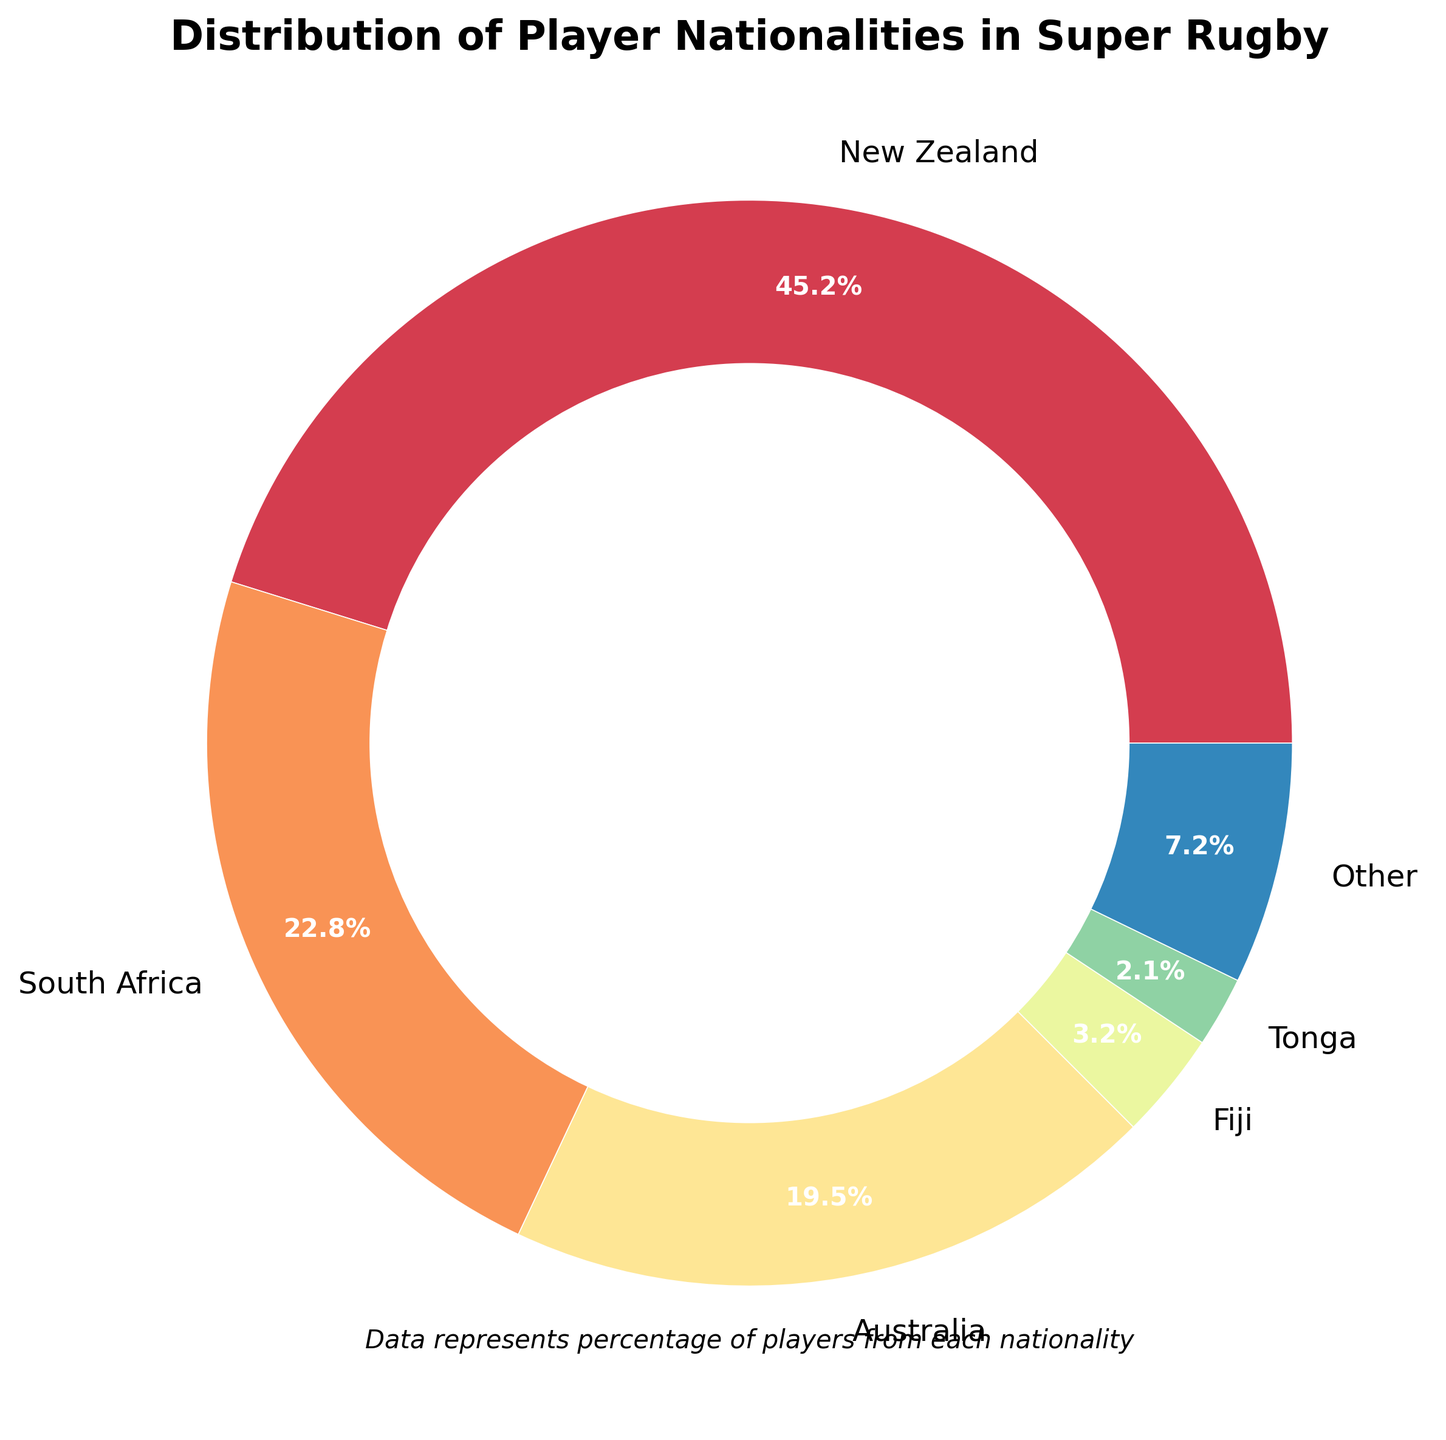Which nationality has the highest percentage of players in Super Rugby? The nationality with the highest percentage is easily identified by the largest section in the pie chart.
Answer: New Zealand How much higher is the percentage of New Zealand players compared to South African players? Subtract the percentage of South African players from the percentage of New Zealand players: 45.2% - 22.8% = 22.4%
Answer: 22.4% What is the sum of percentages for the three most represented nationalities? Add the percentages for New Zealand, South Africa, and Australia: 45.2% + 22.8% + 19.5% = 87.5%
Answer: 87.5% Do players from Fiji, Tonga, and Samoa together have a higher or lower percentage than Australian players? Sum the percentages of Fiji, Tonga, and Samoa and compare with the percentage for Australia: 3.2% + 2.1% + 1.8% = 7.1%. Since 7.1% < 19.5%, it's lower.
Answer: Lower How many nationalities are represented with a percentage less than 2%? Count the nationalities with percentages less than 2%: Samoa, Argentina, Japan, Pacific Islands, and Other (5 total).
Answer: 5 Which group has a larger percentage, Fiji alone or the combined percentage of Japan and Argentina? Compare the percentage of Fiji with the sum of percentages for Japan and Argentina: 3.2% vs. 1.2% + 1.5% = 2.7%. Fiji has a larger percentage.
Answer: Fiji What is the percentage difference between the smallest and the largest nationality representation? Subtract the smallest percentage (Pacific Islands 0.9%) from the largest percentage (New Zealand 45.2%): 45.2% - 0.9% = 44.3%
Answer: 44.3% If we combine the percentages of the players from the Pacific Islands, what would be their total percentage? Add the percentages for Fiji, Tonga, Samoa, and the Pacific Islands: 3.2% + 2.1% + 1.8% + 0.9% = 8.0%
Answer: 8.0% What percentage of players is represented by nationalities other than New Zealand, South Africa, and Australia? Sum the percentages of the nationalities other than New Zealand, South Africa, and Australia: 3.2% + 2.1% + 1.8% + 1.5% + 1.2% + 0.9% + 1.8% = 12.5%
Answer: 12.5% 